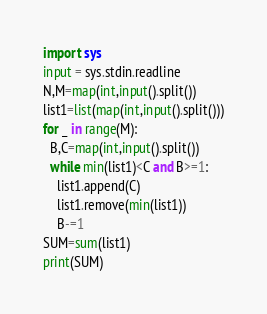Convert code to text. <code><loc_0><loc_0><loc_500><loc_500><_Python_>import sys
input = sys.stdin.readline
N,M=map(int,input().split())
list1=list(map(int,input().split()))
for _ in range(M):
  B,C=map(int,input().split())
  while min(list1)<C and B>=1:
    list1.append(C)
    list1.remove(min(list1))
    B-=1
SUM=sum(list1)
print(SUM)</code> 